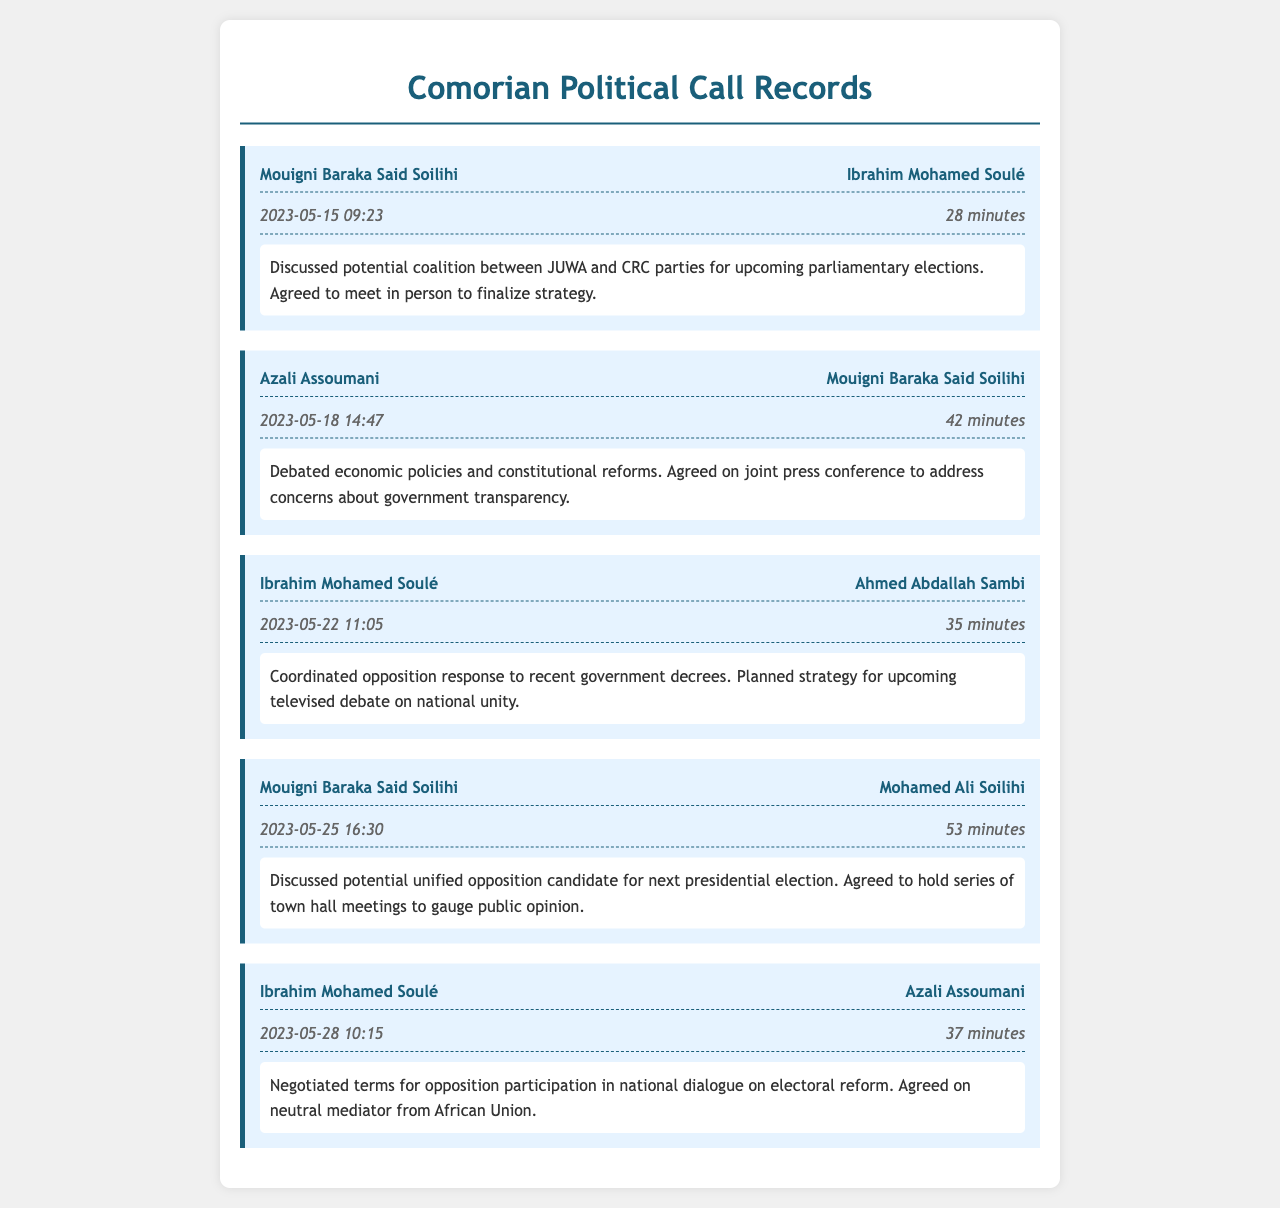What was the duration of the call between Mouigni Baraka Said Soilihi and Ibrahim Mohamed Soulé? The duration of the call is noted as 28 minutes in the document.
Answer: 28 minutes What date did Azali Assoumani and Mouigni Baraka Said Soilihi have their call? The date of the call is recorded as 2023-05-18.
Answer: 2023-05-18 What main topic was discussed in the call between Ibrahim Mohamed Soulé and Ahmed Abdallah Sambi? The main topic discussed was the coordinated opposition response to government decrees.
Answer: Coordinated opposition response How many minutes did the call between Mouigni Baraka Said Soilihi and Mohamed Ali Soilihi last? The call lasted for 53 minutes according to the document.
Answer: 53 minutes Who discussed potential coalition strategies for the upcoming parliamentary elections? Mouigni Baraka Said Soilihi and Ibrahim Mohamed Soulé discussed coalition strategies.
Answer: Mouigni Baraka Said Soilihi and Ibrahim Mohamed Soulé What organization did the opposition agree to use as a neutral mediator for dialogue? The document mentions that the opposition agreed on a mediator from the African Union.
Answer: African Union Which leaders agreed to meet in person to finalize their strategy? The leaders who agreed to meet in person were Mouigni Baraka Said Soilihi and Ibrahim Mohamed Soulé.
Answer: Mouigni Baraka Said Soilihi and Ibrahim Mohamed Soulé What was one of the main agreements made during the call on May 28? One of the main agreements was terms for opposition participation in national dialogue on electoral reform.
Answer: Terms for opposition participation in national dialogue 